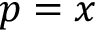Convert formula to latex. <formula><loc_0><loc_0><loc_500><loc_500>p = x</formula> 